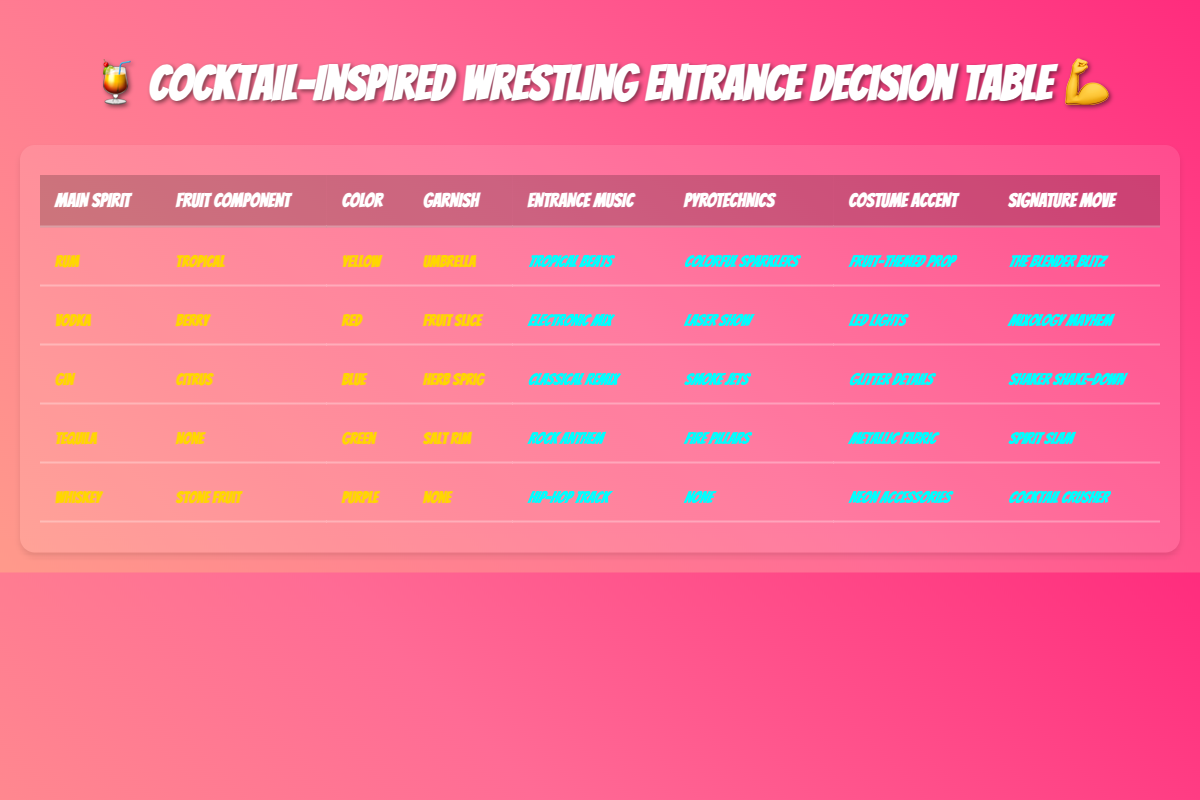What are the entrance music options for all cocktails? The table lists five different cocktails each with their distinct entrance music. They are: Tropical beats, Electronic mix, Classical remix, Rock anthem, and Hip-hop track.
Answer: Tropical beats, Electronic mix, Classical remix, Rock anthem, Hip-hop track Which cocktail has the color yellow? By looking at the table, the cocktail with the color yellow is Rum.
Answer: Rum Is there a cocktail that uses Citrus as a fruit component? Yes, the cocktail with Citrus as the fruit component is Gin.
Answer: Yes What combo of spirit and garnish provides a 'fire pillars' pyrotechnic effect? The table shows that Tequila with a Salt rim leads to the 'fire pillars' pyrotechnic effect.
Answer: Tequila and Salt rim Which cocktail has the signature move 'Mixology Mayhem'? The table indicates that the signature move 'Mixology Mayhem' is associated with Vodka as the main spirit, Berry as the fruit component, Red as the color, and a Fruit slice garnish.
Answer: Vodka If I want a colorful display, which entrance routine should I choose? For a colorful display, the routines with colorful pyrotechnics include Rum with colorful sparklers and Tequila with fire pillars. Both options can be chosen based on the type of spirit and other conditions.
Answer: Rum (colorful sparklers) or Tequila (fire pillars) Which fruit component is paired with whiskey? According to the table, the fruit component that accompanies Whiskey is Stone fruit.
Answer: Stone fruit What is the most colorful costume accent in the table? The most colorful costume accent listed is the Neon accessories associated with Whiskey, while Glitter details belong to Gin too but are less vivid.
Answer: Neon accessories Which spirit results in no pyrotechnics? The table shows that the spirit Whiskey results in no pyrotechnics at all.
Answer: Whiskey 